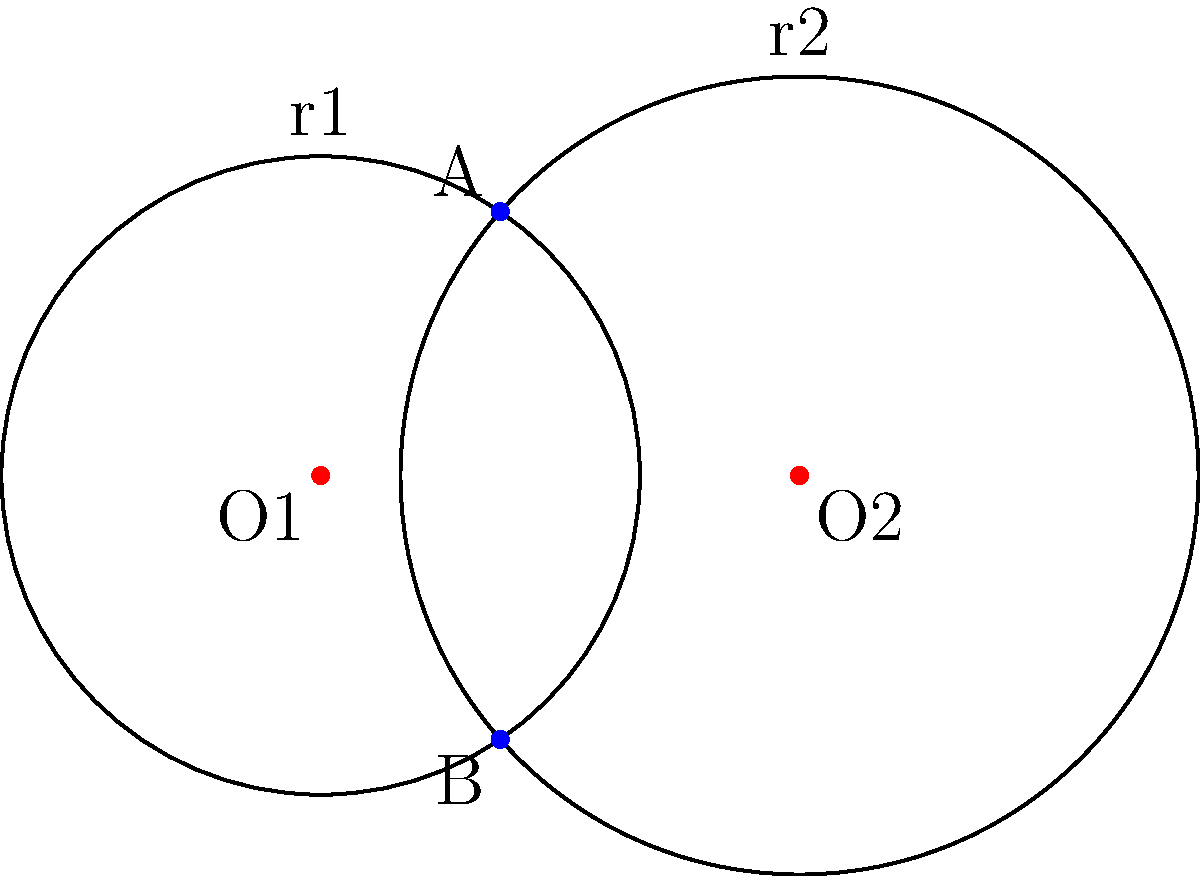Given two circles with centers $O_1(0,0)$ and $O_2(3,0)$, and radii $r_1=2$ and $r_2=2.5$ respectively, calculate the y-coordinates of the intersection points A and B. Round your answer to three decimal places. To find the y-coordinates of the intersection points, we can follow these steps:

1) The general equation for a circle is $(x-h)^2 + (y-k)^2 = r^2$, where $(h,k)$ is the center.

2) For circle 1: $x^2 + y^2 = 4$
   For circle 2: $(x-3)^2 + y^2 = 6.25$

3) To find the intersection points, we need to solve these equations simultaneously.

4) Subtracting the first equation from the second:
   $(x-3)^2 - x^2 = 6.25 - 4$
   $x^2 - 6x + 9 - x^2 = 2.25$
   $-6x = -6.75$
   $x = 1.125$

5) Substitute this x-value back into the equation of circle 1:
   $(1.125)^2 + y^2 = 4$
   $y^2 = 4 - 1.265625 = 2.734375$
   $y = \pm \sqrt{2.734375} \approx \pm 1.654$

6) Therefore, the y-coordinates of the intersection points are approximately 1.654 and -1.654.

7) Rounding to three decimal places: 1.654 and -1.654.
Answer: 1.654, -1.654 